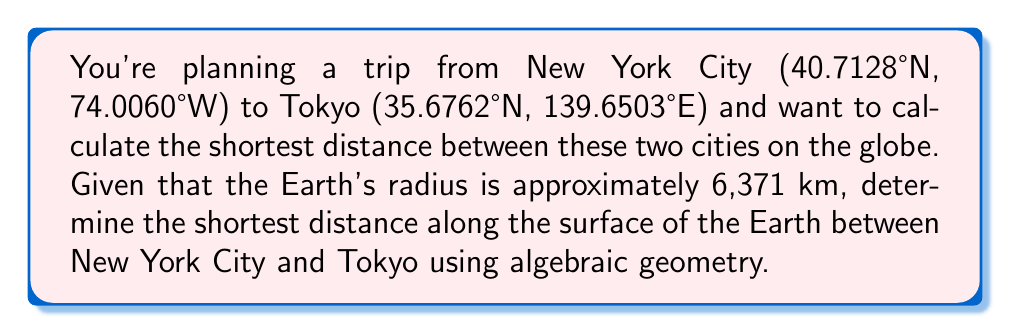What is the answer to this math problem? To calculate the shortest distance between two points on a sphere (in this case, the Earth), we'll use the great circle distance formula derived from spherical trigonometry:

1. Convert the latitudes and longitudes to radians:
   $$\begin{align}
   \phi_1 &= 40.7128° \cdot \frac{\pi}{180} = 0.7101 \text{ radians} \\
   \lambda_1 &= -74.0060° \cdot \frac{\pi}{180} = -1.2915 \text{ radians} \\
   \phi_2 &= 35.6762° \cdot \frac{\pi}{180} = 0.6226 \text{ radians} \\
   \lambda_2 &= 139.6503° \cdot \frac{\pi}{180} = 2.4372 \text{ radians}
   \end{align}$$

2. Calculate the central angle $\Delta \sigma$ using the Haversine formula:
   $$\Delta \sigma = 2 \arcsin\left(\sqrt{\sin^2\left(\frac{\phi_2 - \phi_1}{2}\right) + \cos\phi_1 \cos\phi_2 \sin^2\left(\frac{\lambda_2 - \lambda_1}{2}\right)}\right)$$

3. Substitute the values:
   $$\begin{align}
   \Delta \sigma &= 2 \arcsin\left(\sqrt{\sin^2\left(\frac{0.6226 - 0.7101}{2}\right) + \cos(0.7101) \cos(0.6226) \sin^2\left(\frac{2.4372 - (-1.2915)}{2}\right)}\right) \\
   &= 2 \arcsin\left(\sqrt{\sin^2(-0.04375) + \cos(0.7101) \cos(0.6226) \sin^2(1.86435)}\right) \\
   &= 2 \arcsin(\sqrt{0.001914 + 0.7485 \cdot 0.8198 \cdot 0.8644}) \\
   &= 2 \arcsin(\sqrt{0.001914 + 0.5305}) \\
   &= 2 \arcsin(\sqrt{0.5324}) \\
   &= 2 \arcsin(0.7296) \\
   &= 1.6348 \text{ radians}
   \end{align}$$

4. Calculate the distance $d$ along the surface of the Earth:
   $$\begin{align}
   d &= R \cdot \Delta \sigma \\
   &= 6371 \text{ km} \cdot 1.6348 \\
   &= 10,414.7 \text{ km}
   \end{align}$$

Thus, the shortest distance between New York City and Tokyo along the surface of the Earth is approximately 10,414.7 km.
Answer: 10,414.7 km 